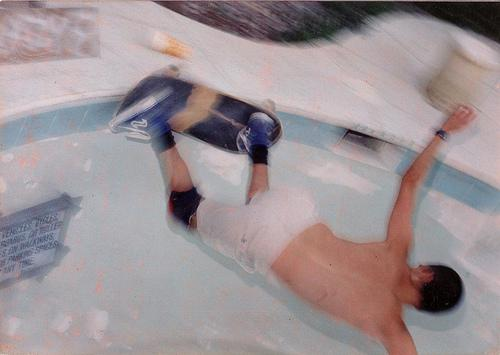Question: who is in the picture?
Choices:
A. A young woman.
B. A child.
C. A young man.
D. An elderly man.
Answer with the letter. Answer: C Question: what sport is depicted?
Choices:
A. Skateboarding.
B. Football.
C. Baseball.
D. Lacrosse.
Answer with the letter. Answer: A Question: what is he skating on?
Choices:
A. An empty swimming pool.
B. A skate park.
C. A railing.
D. A parking lot.
Answer with the letter. Answer: A Question: how many faces are in the picture?
Choices:
A. One.
B. Two.
C. Three.
D. Zero.
Answer with the letter. Answer: D Question: what color are the man's shoes?
Choices:
A. Blue and white.
B. Black.
C. White.
D. Blue.
Answer with the letter. Answer: A Question: what safety equipment is the man wearing?
Choices:
A. Knee pads.
B. Safety glasses.
C. A helmet.
D. Work gloves.
Answer with the letter. Answer: A Question: what is on the man's left wrist?
Choices:
A. A watch.
B. A bracelet.
C. A ring.
D. Nothing.
Answer with the letter. Answer: A 